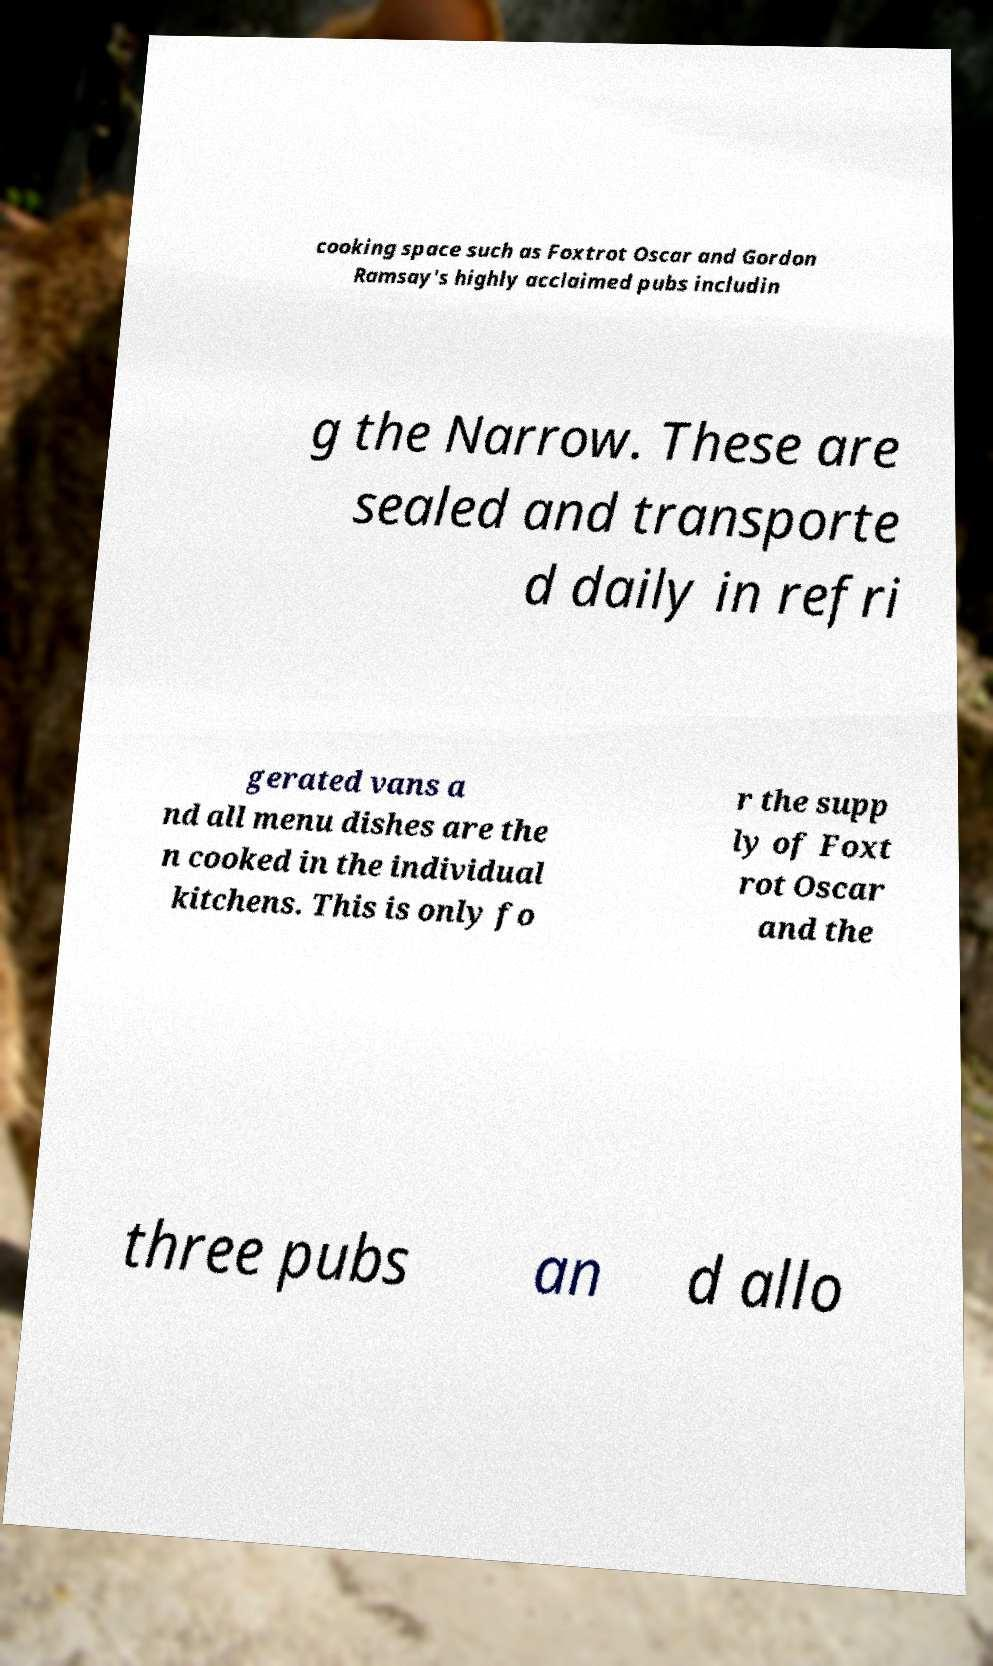What messages or text are displayed in this image? I need them in a readable, typed format. cooking space such as Foxtrot Oscar and Gordon Ramsay's highly acclaimed pubs includin g the Narrow. These are sealed and transporte d daily in refri gerated vans a nd all menu dishes are the n cooked in the individual kitchens. This is only fo r the supp ly of Foxt rot Oscar and the three pubs an d allo 